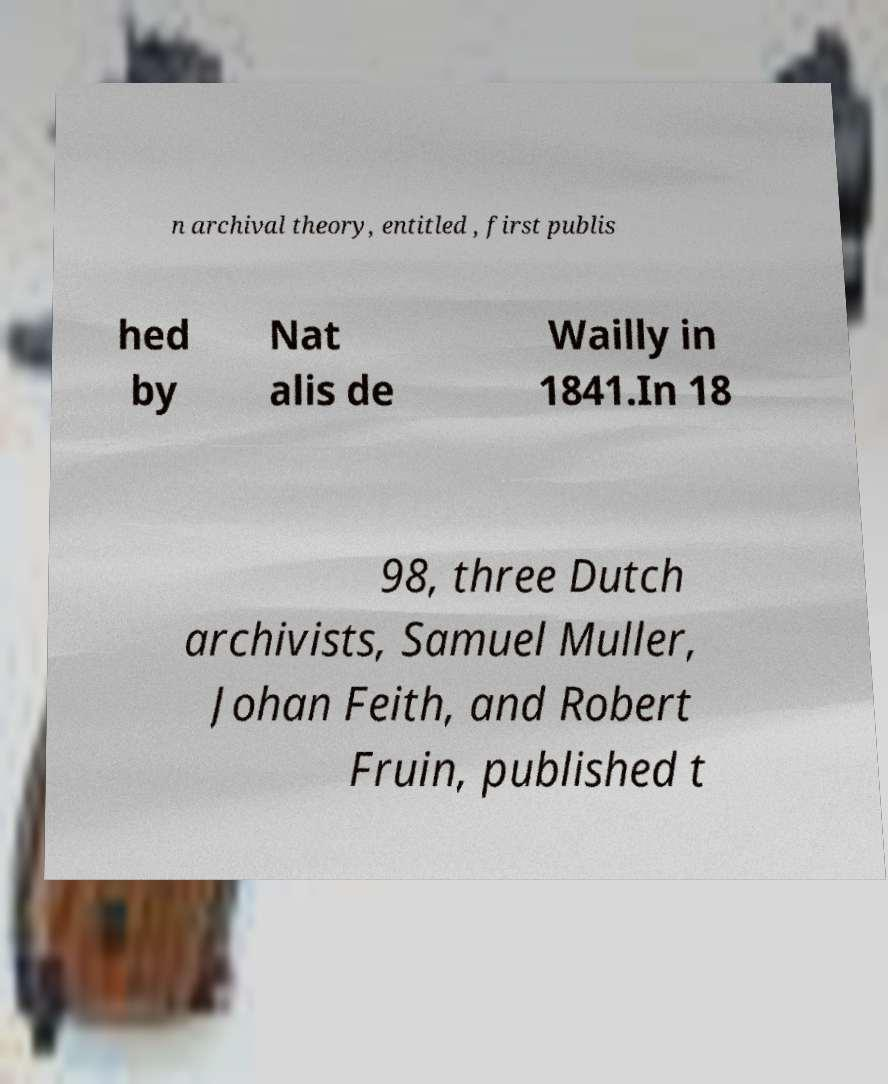I need the written content from this picture converted into text. Can you do that? n archival theory, entitled , first publis hed by Nat alis de Wailly in 1841.In 18 98, three Dutch archivists, Samuel Muller, Johan Feith, and Robert Fruin, published t 